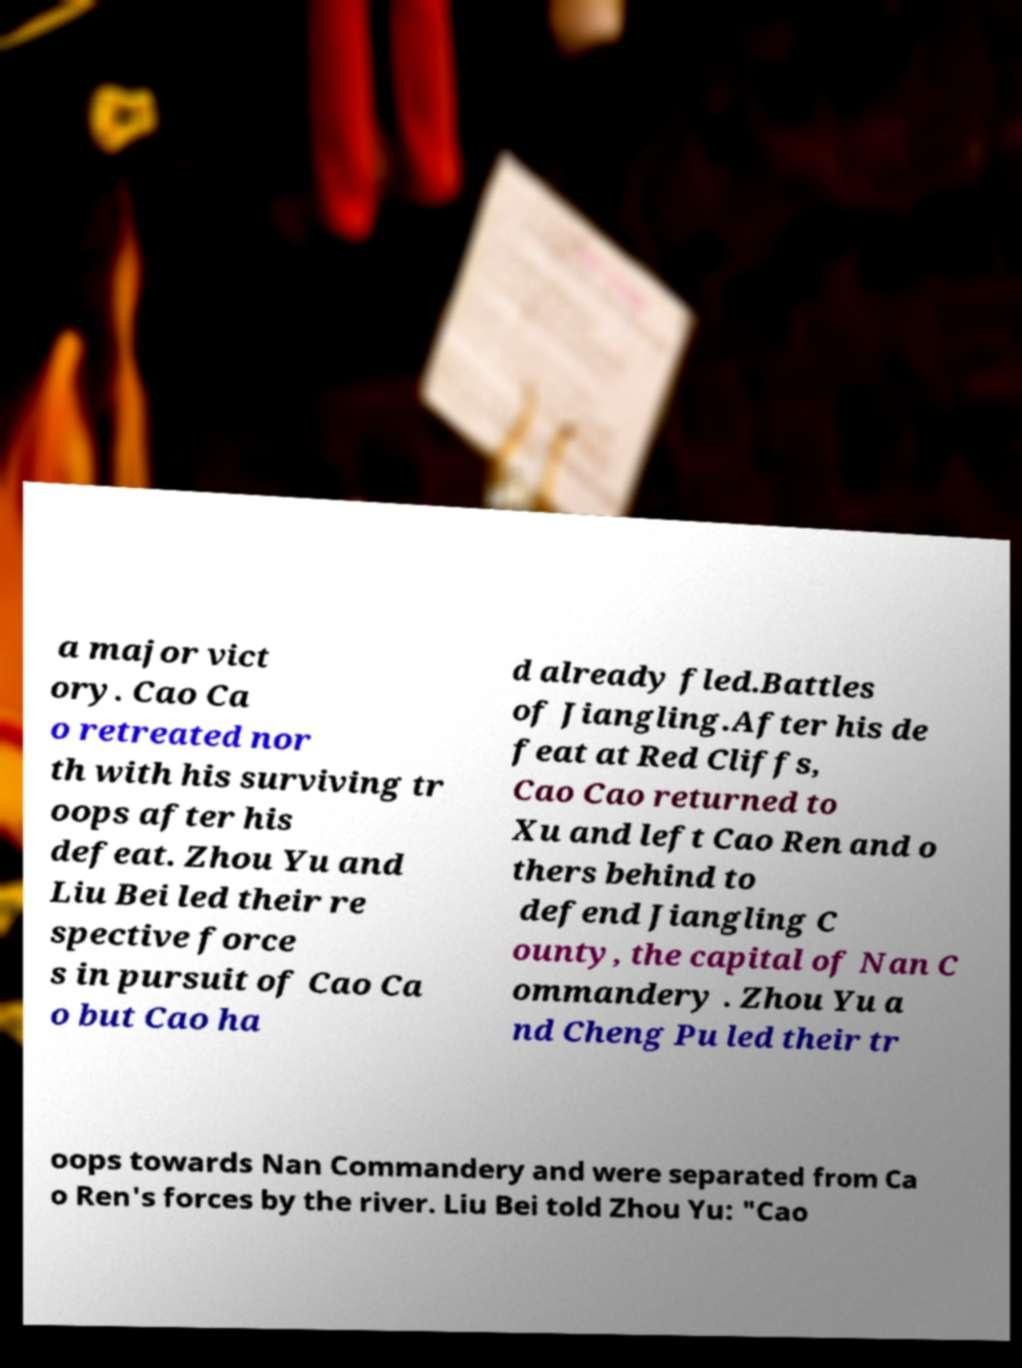Please read and relay the text visible in this image. What does it say? a major vict ory. Cao Ca o retreated nor th with his surviving tr oops after his defeat. Zhou Yu and Liu Bei led their re spective force s in pursuit of Cao Ca o but Cao ha d already fled.Battles of Jiangling.After his de feat at Red Cliffs, Cao Cao returned to Xu and left Cao Ren and o thers behind to defend Jiangling C ounty, the capital of Nan C ommandery . Zhou Yu a nd Cheng Pu led their tr oops towards Nan Commandery and were separated from Ca o Ren's forces by the river. Liu Bei told Zhou Yu: "Cao 